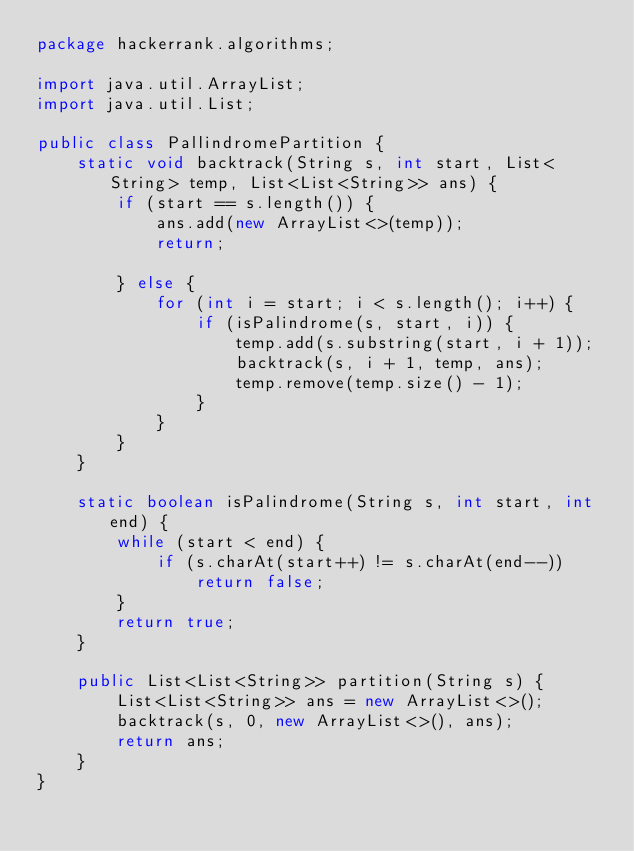<code> <loc_0><loc_0><loc_500><loc_500><_Java_>package hackerrank.algorithms;

import java.util.ArrayList;
import java.util.List;

public class PallindromePartition {
    static void backtrack(String s, int start, List<String> temp, List<List<String>> ans) {
        if (start == s.length()) {
            ans.add(new ArrayList<>(temp));
            return;

        } else {
            for (int i = start; i < s.length(); i++) {
                if (isPalindrome(s, start, i)) {
                    temp.add(s.substring(start, i + 1));
                    backtrack(s, i + 1, temp, ans);
                    temp.remove(temp.size() - 1);
                }
            }
        }
    }

    static boolean isPalindrome(String s, int start, int end) {
        while (start < end) {
            if (s.charAt(start++) != s.charAt(end--))
                return false;
        }
        return true;
    }

    public List<List<String>> partition(String s) {
        List<List<String>> ans = new ArrayList<>();
        backtrack(s, 0, new ArrayList<>(), ans);
        return ans;
    }
}
</code> 